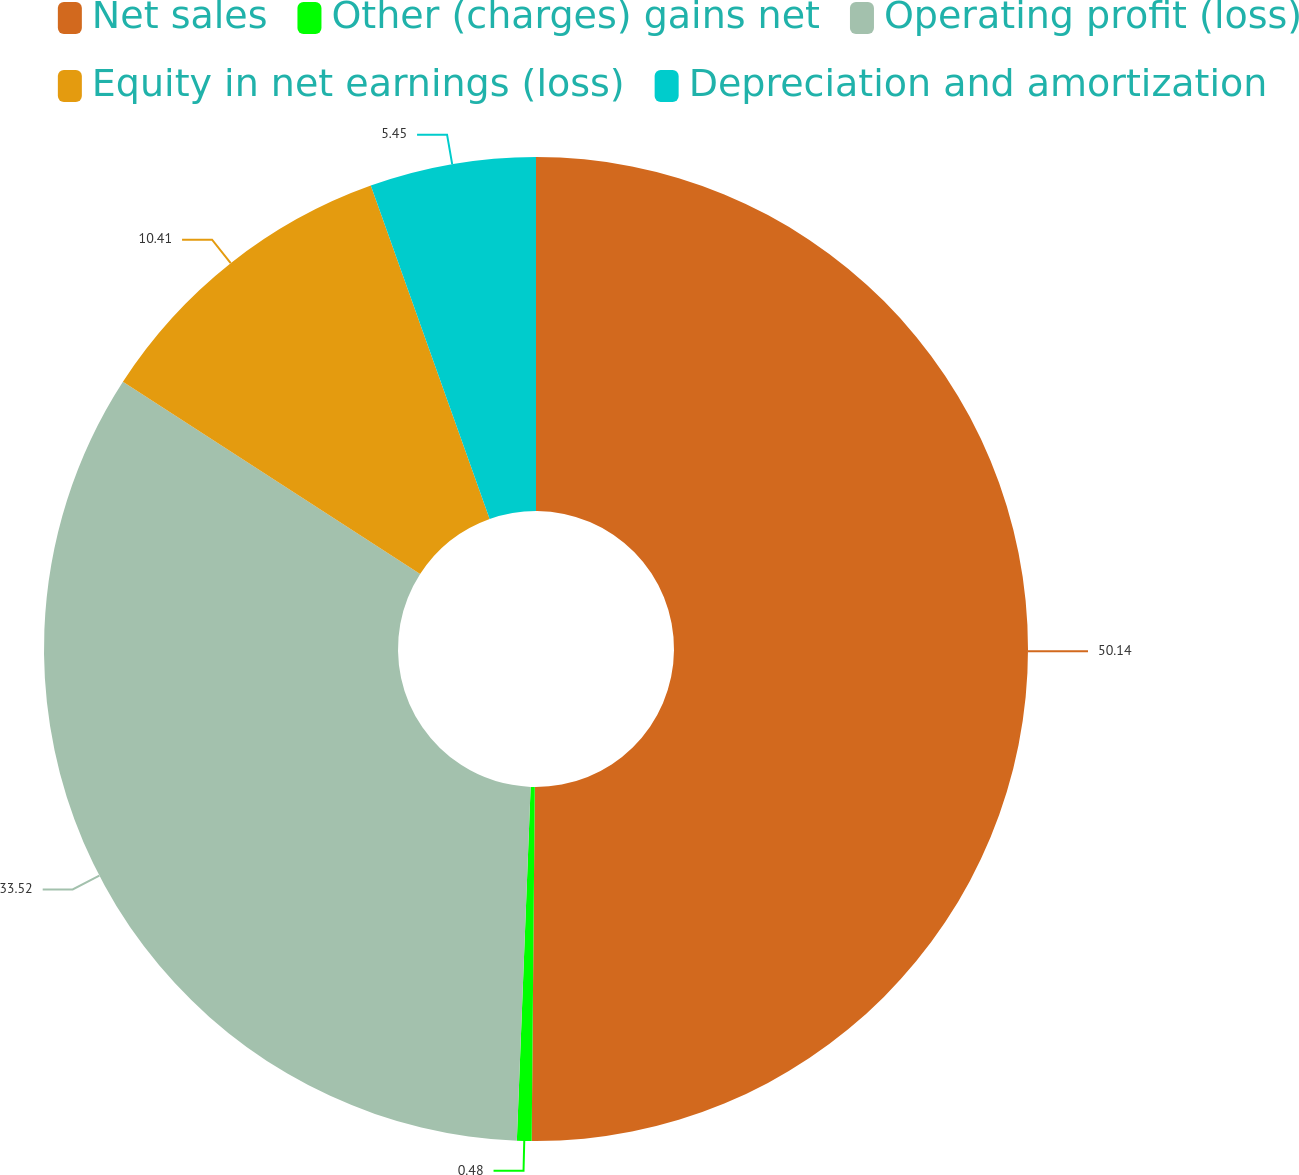Convert chart to OTSL. <chart><loc_0><loc_0><loc_500><loc_500><pie_chart><fcel>Net sales<fcel>Other (charges) gains net<fcel>Operating profit (loss)<fcel>Equity in net earnings (loss)<fcel>Depreciation and amortization<nl><fcel>50.14%<fcel>0.48%<fcel>33.52%<fcel>10.41%<fcel>5.45%<nl></chart> 